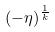<formula> <loc_0><loc_0><loc_500><loc_500>( - \eta ) ^ { \frac { 1 } { k } }</formula> 